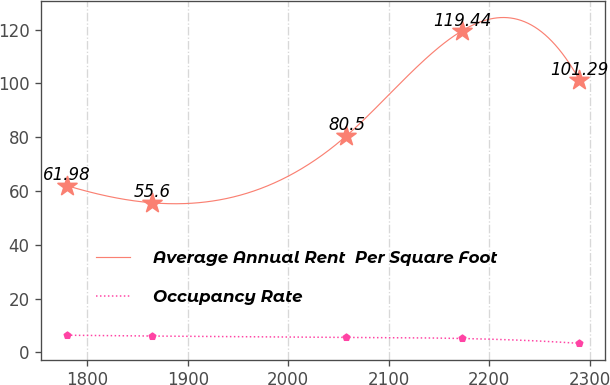Convert chart to OTSL. <chart><loc_0><loc_0><loc_500><loc_500><line_chart><ecel><fcel>Average Annual Rent  Per Square Foot<fcel>Occupancy Rate<nl><fcel>1779.62<fcel>61.98<fcel>6.39<nl><fcel>1864.45<fcel>55.6<fcel>6.09<nl><fcel>2057.91<fcel>80.5<fcel>5.61<nl><fcel>2172.66<fcel>119.44<fcel>5.18<nl><fcel>2289.85<fcel>101.29<fcel>3.37<nl></chart> 